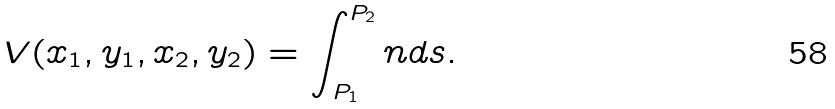Convert formula to latex. <formula><loc_0><loc_0><loc_500><loc_500>V ( x _ { 1 } , y _ { 1 } , x _ { 2 } , y _ { 2 } ) = \int _ { P _ { 1 } } ^ { P _ { 2 } } n d s .</formula> 